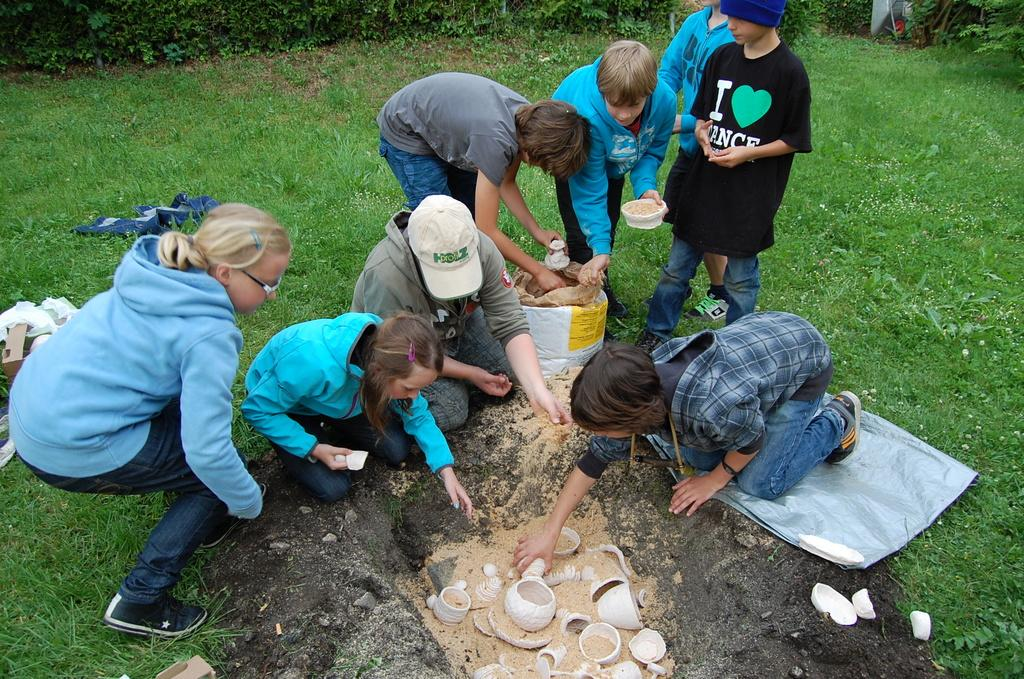How many people are in the image? There is a group of people in the image, but the exact number cannot be determined from the provided facts. What are the people doing in the image? The people are on the ground, but their specific activity is not mentioned in the facts. What objects can be seen in the image besides the people? There are cups visible in the image. What type of environment is visible in the background of the image? The background of the image includes grass and trees, which suggests a natural setting, possibly a park. What type of cart is being used to develop the reward system in the image? There is no cart, development, or reward system present in the image. 